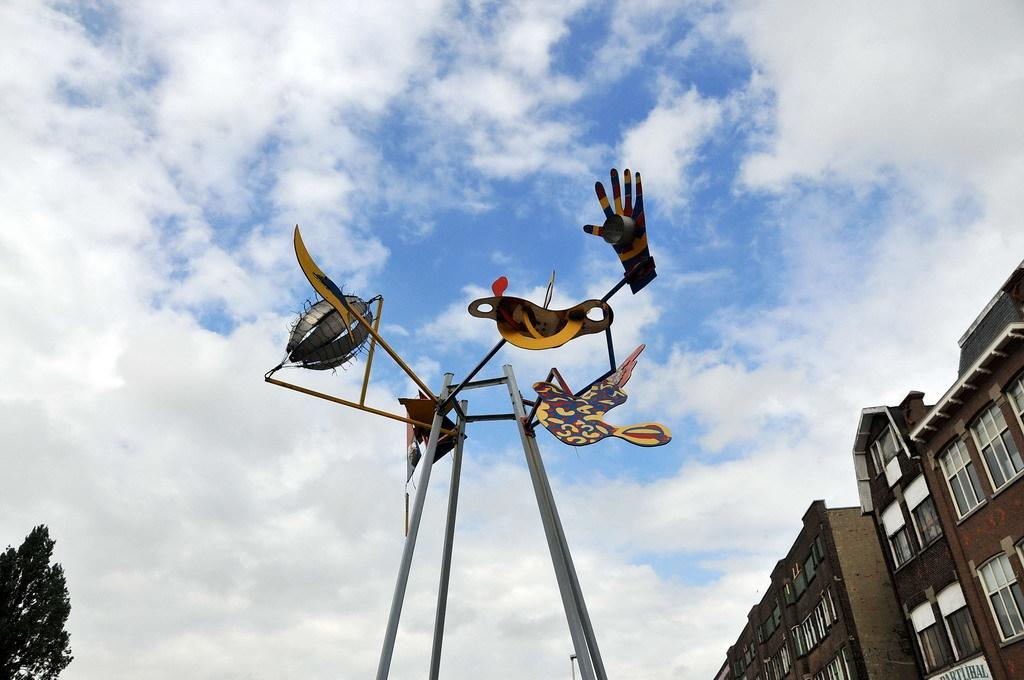How would you summarize this image in a sentence or two? In this picture we can see the clear blue sky with clouds. On the right side we can see buildings and in the left bottom corner we can see a tree. This picture is mainly highlighted with a boards of hand, bird and other objects to the poles. 